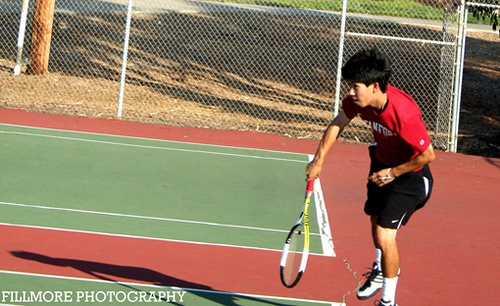Describe the objects in this image and their specific colors. I can see people in darkgray, black, tan, maroon, and red tones and tennis racket in darkgray, white, olive, and salmon tones in this image. 